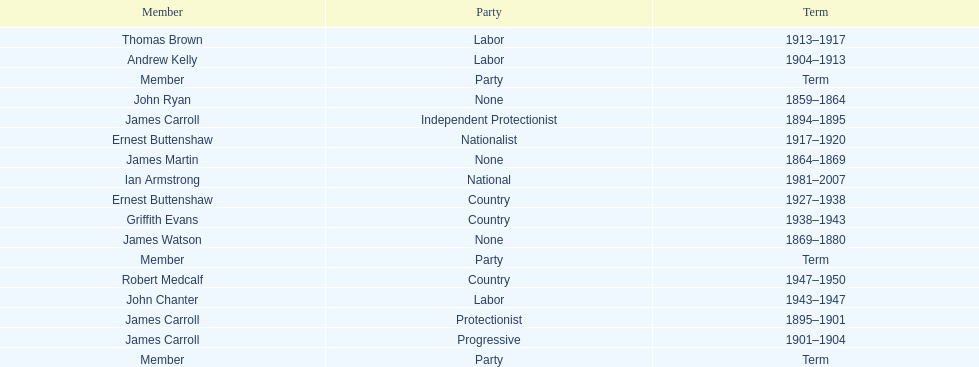How long did ian armstrong serve? 26 years. 